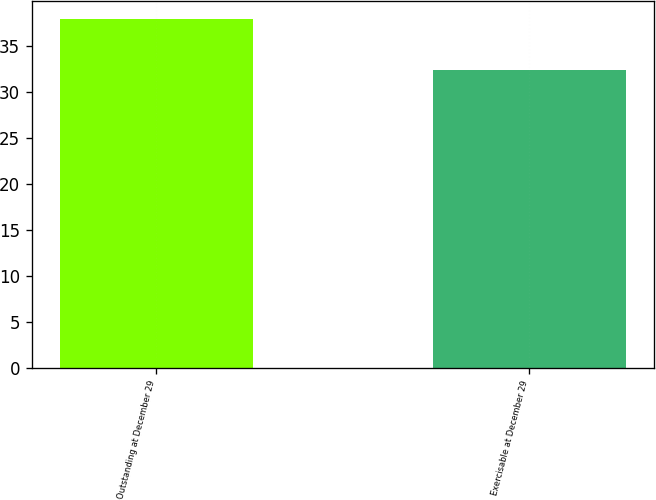<chart> <loc_0><loc_0><loc_500><loc_500><bar_chart><fcel>Outstanding at December 29<fcel>Exercisable at December 29<nl><fcel>37.98<fcel>32.4<nl></chart> 